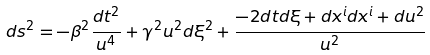<formula> <loc_0><loc_0><loc_500><loc_500>d s ^ { 2 } = - \beta ^ { 2 } \frac { d t ^ { 2 } } { u ^ { 4 } } + \gamma ^ { 2 } u ^ { 2 } d \xi ^ { 2 } + \frac { - 2 d t d \xi + d x ^ { i } d x ^ { i } + d u ^ { 2 } } { u ^ { 2 } }</formula> 